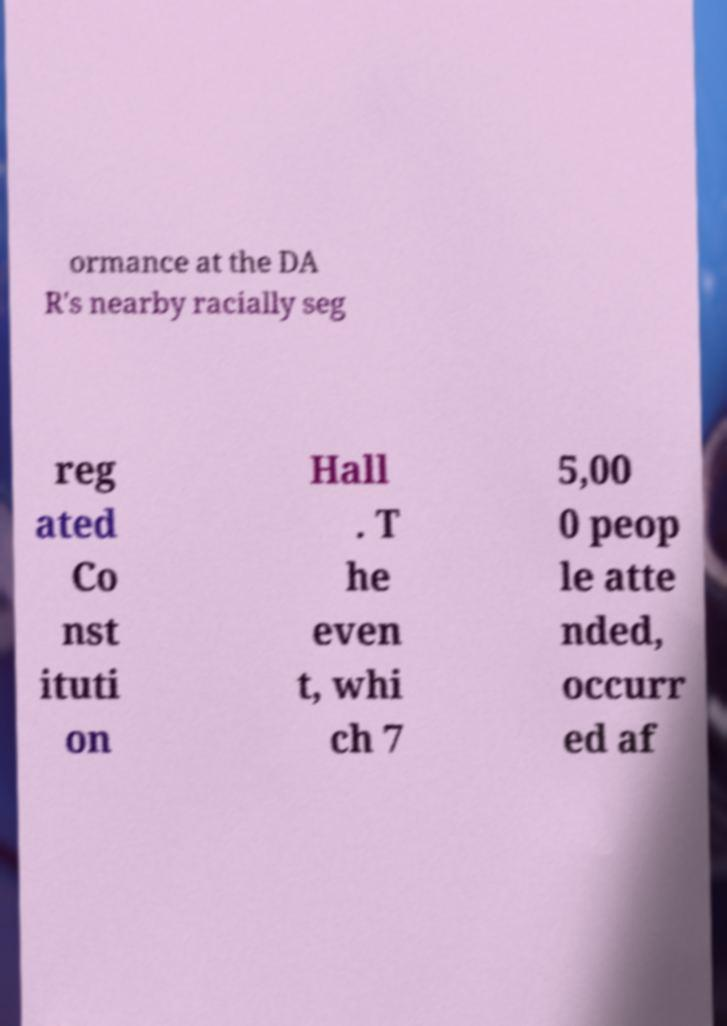Please identify and transcribe the text found in this image. ormance at the DA R's nearby racially seg reg ated Co nst ituti on Hall . T he even t, whi ch 7 5,00 0 peop le atte nded, occurr ed af 